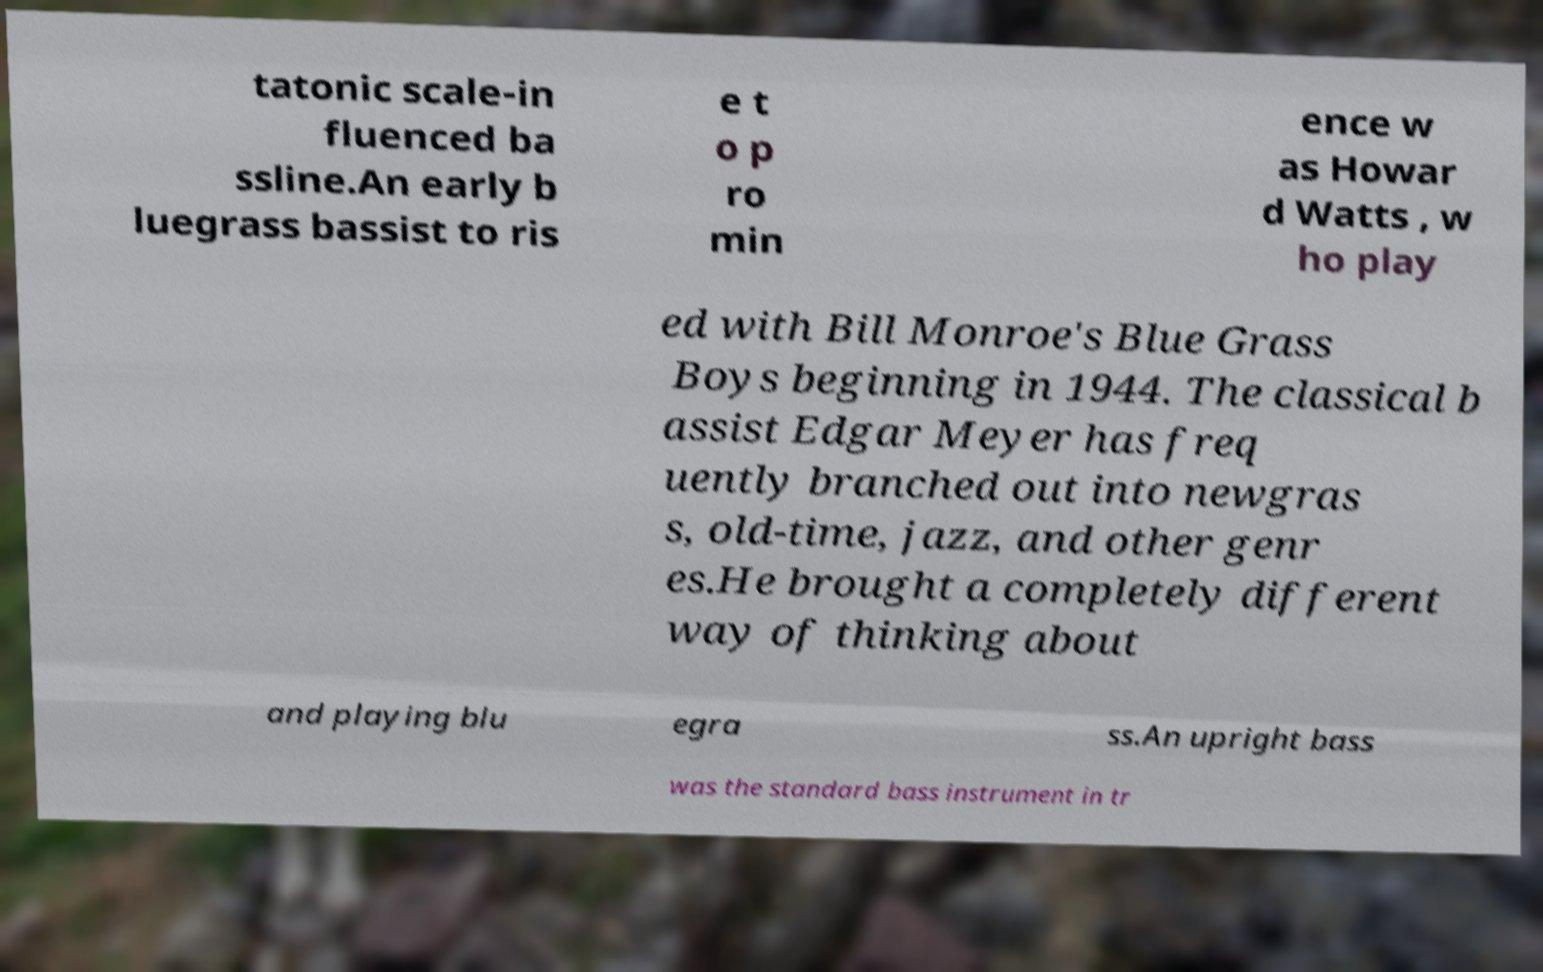What messages or text are displayed in this image? I need them in a readable, typed format. tatonic scale-in fluenced ba ssline.An early b luegrass bassist to ris e t o p ro min ence w as Howar d Watts , w ho play ed with Bill Monroe's Blue Grass Boys beginning in 1944. The classical b assist Edgar Meyer has freq uently branched out into newgras s, old-time, jazz, and other genr es.He brought a completely different way of thinking about and playing blu egra ss.An upright bass was the standard bass instrument in tr 